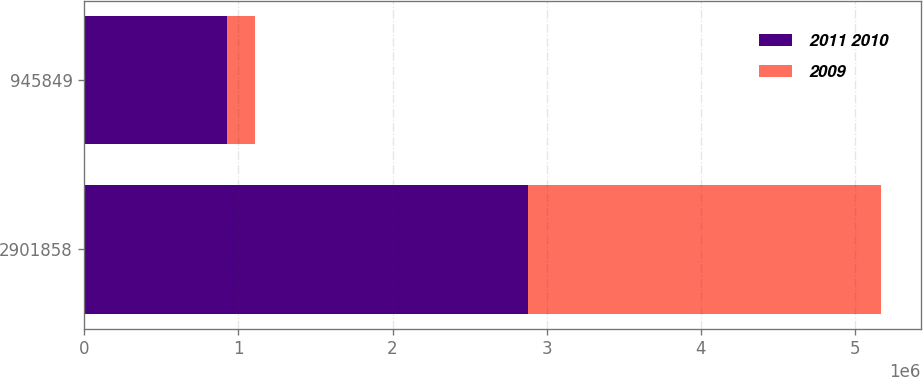<chart> <loc_0><loc_0><loc_500><loc_500><stacked_bar_chart><ecel><fcel>2901858<fcel>945849<nl><fcel>2011 2010<fcel>2.87689e+06<fcel>924973<nl><fcel>2009<fcel>2.29045e+06<fcel>183835<nl></chart> 